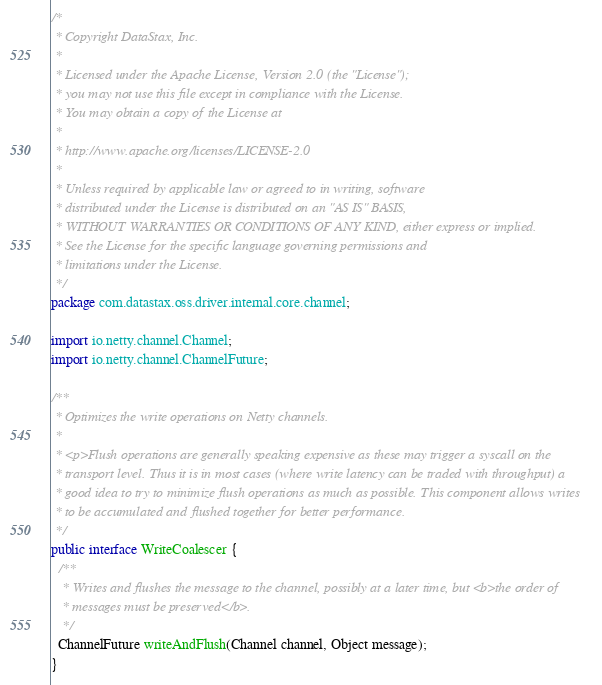Convert code to text. <code><loc_0><loc_0><loc_500><loc_500><_Java_>/*
 * Copyright DataStax, Inc.
 *
 * Licensed under the Apache License, Version 2.0 (the "License");
 * you may not use this file except in compliance with the License.
 * You may obtain a copy of the License at
 *
 * http://www.apache.org/licenses/LICENSE-2.0
 *
 * Unless required by applicable law or agreed to in writing, software
 * distributed under the License is distributed on an "AS IS" BASIS,
 * WITHOUT WARRANTIES OR CONDITIONS OF ANY KIND, either express or implied.
 * See the License for the specific language governing permissions and
 * limitations under the License.
 */
package com.datastax.oss.driver.internal.core.channel;

import io.netty.channel.Channel;
import io.netty.channel.ChannelFuture;

/**
 * Optimizes the write operations on Netty channels.
 *
 * <p>Flush operations are generally speaking expensive as these may trigger a syscall on the
 * transport level. Thus it is in most cases (where write latency can be traded with throughput) a
 * good idea to try to minimize flush operations as much as possible. This component allows writes
 * to be accumulated and flushed together for better performance.
 */
public interface WriteCoalescer {
  /**
   * Writes and flushes the message to the channel, possibly at a later time, but <b>the order of
   * messages must be preserved</b>.
   */
  ChannelFuture writeAndFlush(Channel channel, Object message);
}
</code> 